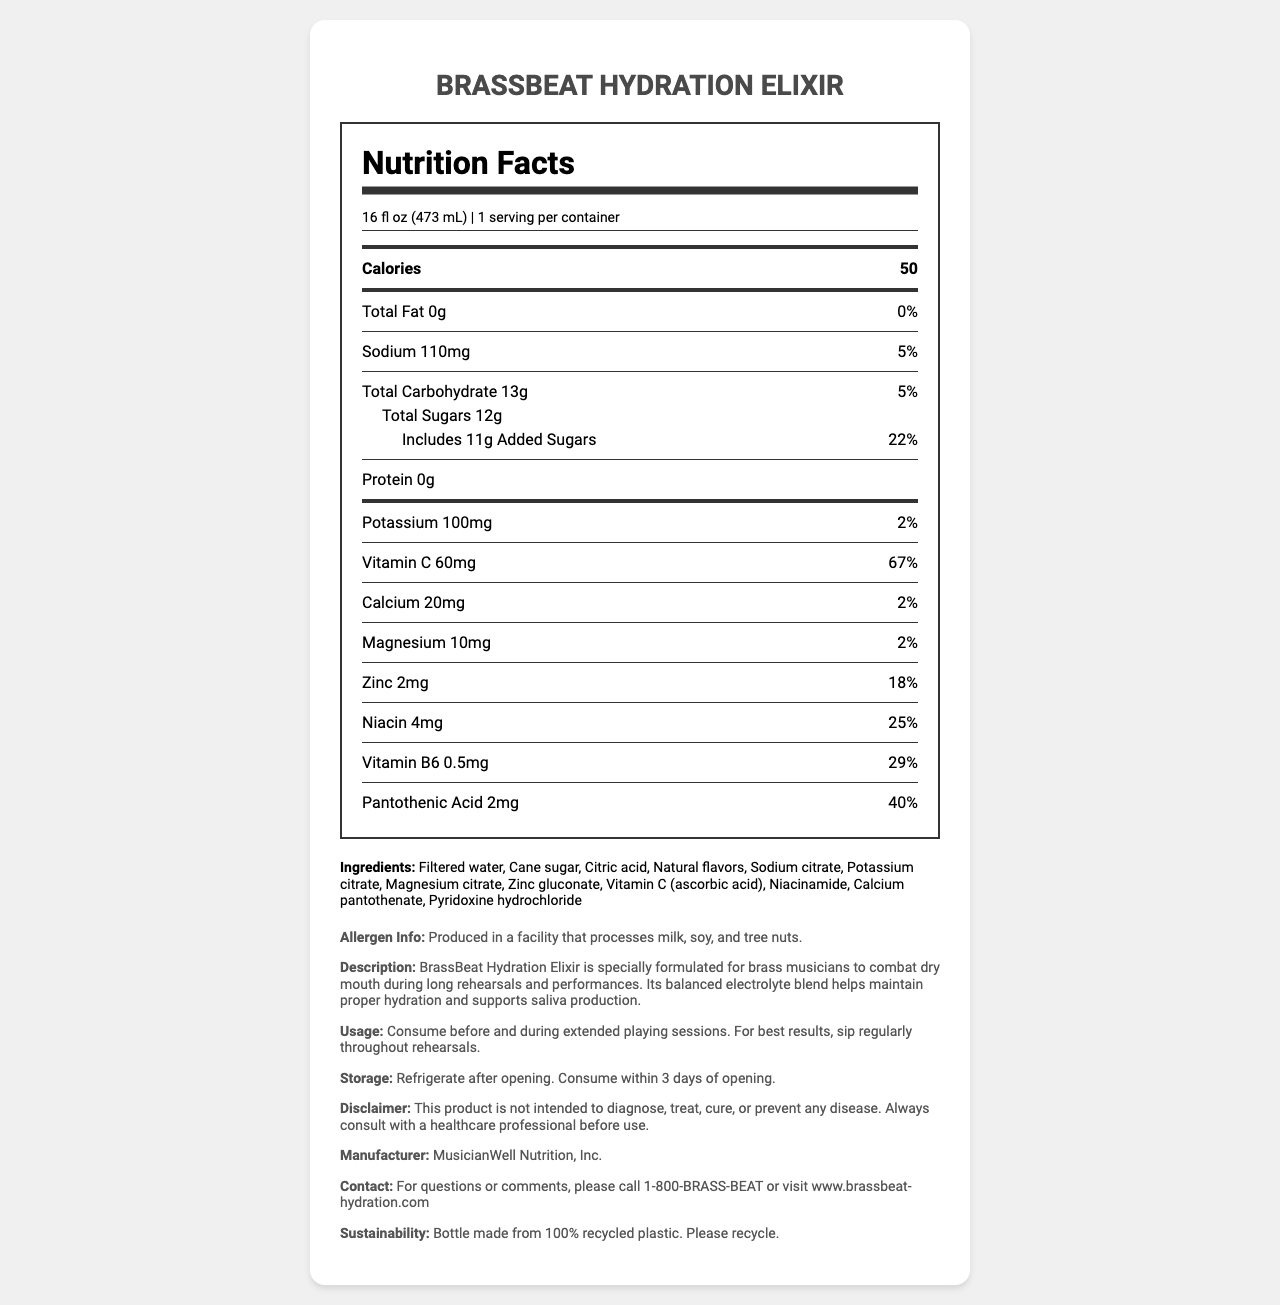what is the name of the hydration beverage? The product name listed at the top of the document is BrassBeat Hydration Elixir.
Answer: BrassBeat Hydration Elixir what is the serving size of BrassBeat Hydration Elixir? The serving size is stated as 16 fl oz (473 mL).
Answer: 16 fl oz (473 mL) how many calories are there in one serving of BrassBeat Hydration Elixir? The nutrition facts mention that one serving of the beverage contains 50 calories.
Answer: 50 what is the total amount of sugars per serving? Under the Total Sugars section, it lists 12g of total sugars per serving.
Answer: 12g how much potassium does the beverage contain? The nutrition facts indicate that the beverage contains 100mg of potassium.
Answer: 100mg which ingredient is used as a source of Vitamin C in the beverage? The ingredients list includes "Vitamin C (ascorbic acid)" as a source of Vitamin C.
Answer: Ascorbic acid is BrassBeat Hydration Elixir recommended for consumption during rehearsals? The product description and usage instructions advocate for consumption before and during extended playing sessions for best results.
Answer: Yes who manufactures BrassBeat Hydration Elixir? The manufacturer is listed as MusicianWell Nutrition, Inc. in the product information section.
Answer: MusicianWell Nutrition, Inc. what is the percentage daily value (%DV) of sodium in one serving? The nutrition facts show that the sodium content in one serving is 5% of the daily value.
Answer: 5% what are the main benefits described for this hydration beverage? The product description states that the beverage helps brass musicians combat dry mouth and maintain proper hydration to support saliva production.
Answer: Maintaining proper hydration and supporting saliva production which mineral in the beverage has the highest %DV? A. Potassium B. Calcium C. Magnesium D. Zinc Zinc has an 18% daily value, which is the highest among the minerals listed.
Answer: D. Zinc how much Vitamin B6 is in one serving of the beverage? The nutrition facts indicate that there is 0.5mg of Vitamin B6 per serving.
Answer: 0.5mg in addition to potassium citrate, which other electrolyte is present as a citrate? A. Sodium B. Calcium C. Magnesium Both potassium citrate and magnesium citrate are listed in the ingredients.
Answer: C. Magnesium what is the primary sugar source in the drink? The ingredients list includes cane sugar.
Answer: Cane sugar what precaution should you take if you have allergies to certain common allergens? The allergen information states that the product is made in a facility that processes milk, soy, and tree nuts.
Answer: Be cautious as it is produced in a facility that processes milk, soy, and tree nuts when should you refrigerate BrassBeat Hydration Elixir? The storage instructions advise refrigerating the beverage after opening.
Answer: After opening is this product intended to diagnose or treat any disease? The disclaimer explicitly states that the product is not intended to diagnose, treat, cure, or prevent any disease.
Answer: No how do you use BrassBeat Hydration Elixir for best results? The usage instructions recommend sipping the beverage regularly throughout rehearsals.
Answer: Sip regularly throughout rehearsals is the bottle made from recycled material? The sustainability info mentions that the bottle is made from 100% recycled plastic.
Answer: Yes summarize the purpose of the document and the main features of BrassBeat Hydration Elixir The document aims to inform users about the nutritional content, benefits, and usage of BrassBeat Hydration Elixir while also highlighting its ingredients, potential allergens, and the recyclable nature of its bottle.
Answer: The document provides comprehensive information about BrassBeat Hydration Elixir, a hydration beverage designed for brass musicians to combat dry mouth and maintain hydration. It includes nutritional facts, ingredients, usage instructions, storage guidelines, allergen info, manufacturer details, and sustainability efforts. what are the sales figures for BrassBeat Hydration Elixir last year? The document does not provide any sales figures or related financial data.
Answer: Not enough information 